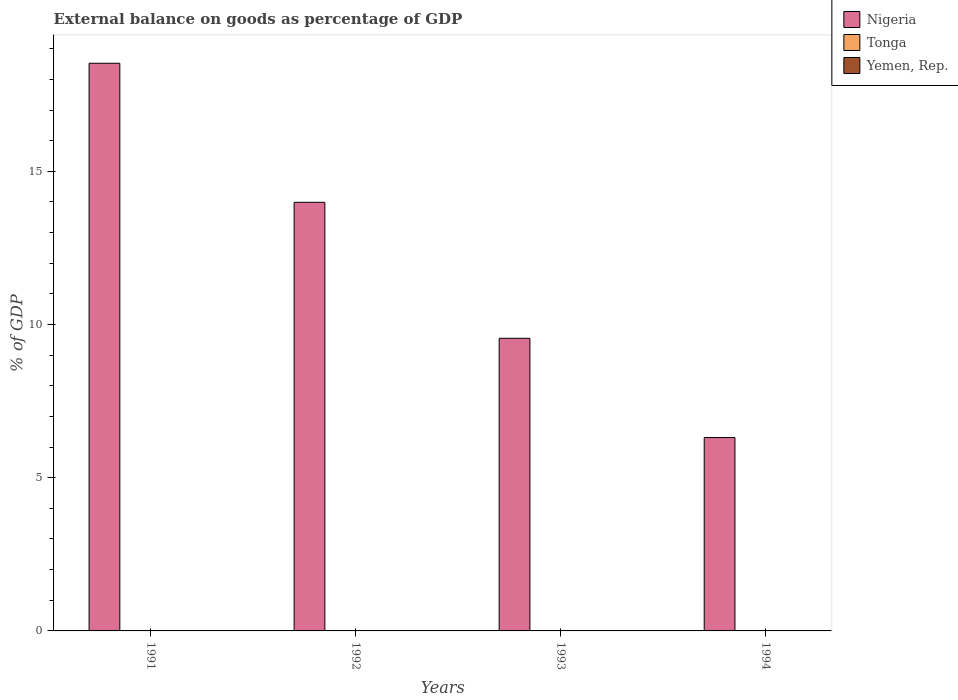How many different coloured bars are there?
Your response must be concise. 1. What is the label of the 2nd group of bars from the left?
Provide a short and direct response. 1992. Across all years, what is the maximum external balance on goods as percentage of GDP in Nigeria?
Your response must be concise. 18.53. Across all years, what is the minimum external balance on goods as percentage of GDP in Nigeria?
Your answer should be compact. 6.31. In which year was the external balance on goods as percentage of GDP in Nigeria maximum?
Your response must be concise. 1991. What is the difference between the external balance on goods as percentage of GDP in Nigeria in 1992 and that in 1993?
Offer a very short reply. 4.44. What is the difference between the external balance on goods as percentage of GDP in Yemen, Rep. in 1993 and the external balance on goods as percentage of GDP in Nigeria in 1994?
Keep it short and to the point. -6.31. In how many years, is the external balance on goods as percentage of GDP in Tonga greater than 16 %?
Your response must be concise. 0. What is the ratio of the external balance on goods as percentage of GDP in Nigeria in 1992 to that in 1993?
Provide a succinct answer. 1.46. What is the difference between the highest and the second highest external balance on goods as percentage of GDP in Nigeria?
Make the answer very short. 4.54. What is the difference between the highest and the lowest external balance on goods as percentage of GDP in Nigeria?
Keep it short and to the point. 12.21. Is the sum of the external balance on goods as percentage of GDP in Nigeria in 1992 and 1993 greater than the maximum external balance on goods as percentage of GDP in Yemen, Rep. across all years?
Keep it short and to the point. Yes. Is it the case that in every year, the sum of the external balance on goods as percentage of GDP in Tonga and external balance on goods as percentage of GDP in Nigeria is greater than the external balance on goods as percentage of GDP in Yemen, Rep.?
Ensure brevity in your answer.  Yes. Are all the bars in the graph horizontal?
Provide a short and direct response. No. How many years are there in the graph?
Ensure brevity in your answer.  4. Does the graph contain grids?
Offer a terse response. No. Where does the legend appear in the graph?
Ensure brevity in your answer.  Top right. What is the title of the graph?
Provide a succinct answer. External balance on goods as percentage of GDP. What is the label or title of the X-axis?
Offer a very short reply. Years. What is the label or title of the Y-axis?
Ensure brevity in your answer.  % of GDP. What is the % of GDP of Nigeria in 1991?
Ensure brevity in your answer.  18.53. What is the % of GDP of Tonga in 1991?
Give a very brief answer. 0. What is the % of GDP of Yemen, Rep. in 1991?
Keep it short and to the point. 0. What is the % of GDP in Nigeria in 1992?
Make the answer very short. 13.99. What is the % of GDP in Tonga in 1992?
Make the answer very short. 0. What is the % of GDP in Yemen, Rep. in 1992?
Your response must be concise. 0. What is the % of GDP of Nigeria in 1993?
Your answer should be very brief. 9.55. What is the % of GDP in Tonga in 1993?
Your answer should be compact. 0. What is the % of GDP in Yemen, Rep. in 1993?
Provide a short and direct response. 0. What is the % of GDP of Nigeria in 1994?
Your answer should be very brief. 6.31. What is the % of GDP of Tonga in 1994?
Provide a short and direct response. 0. Across all years, what is the maximum % of GDP of Nigeria?
Your response must be concise. 18.53. Across all years, what is the minimum % of GDP in Nigeria?
Offer a very short reply. 6.31. What is the total % of GDP of Nigeria in the graph?
Offer a terse response. 48.37. What is the total % of GDP of Tonga in the graph?
Your answer should be compact. 0. What is the difference between the % of GDP in Nigeria in 1991 and that in 1992?
Your response must be concise. 4.54. What is the difference between the % of GDP of Nigeria in 1991 and that in 1993?
Provide a succinct answer. 8.98. What is the difference between the % of GDP in Nigeria in 1991 and that in 1994?
Provide a succinct answer. 12.21. What is the difference between the % of GDP of Nigeria in 1992 and that in 1993?
Offer a terse response. 4.44. What is the difference between the % of GDP in Nigeria in 1992 and that in 1994?
Your answer should be very brief. 7.68. What is the difference between the % of GDP in Nigeria in 1993 and that in 1994?
Keep it short and to the point. 3.24. What is the average % of GDP of Nigeria per year?
Offer a very short reply. 12.09. What is the ratio of the % of GDP in Nigeria in 1991 to that in 1992?
Provide a short and direct response. 1.32. What is the ratio of the % of GDP of Nigeria in 1991 to that in 1993?
Provide a succinct answer. 1.94. What is the ratio of the % of GDP of Nigeria in 1991 to that in 1994?
Provide a short and direct response. 2.94. What is the ratio of the % of GDP of Nigeria in 1992 to that in 1993?
Keep it short and to the point. 1.46. What is the ratio of the % of GDP in Nigeria in 1992 to that in 1994?
Give a very brief answer. 2.22. What is the ratio of the % of GDP in Nigeria in 1993 to that in 1994?
Your response must be concise. 1.51. What is the difference between the highest and the second highest % of GDP in Nigeria?
Provide a succinct answer. 4.54. What is the difference between the highest and the lowest % of GDP of Nigeria?
Provide a succinct answer. 12.21. 